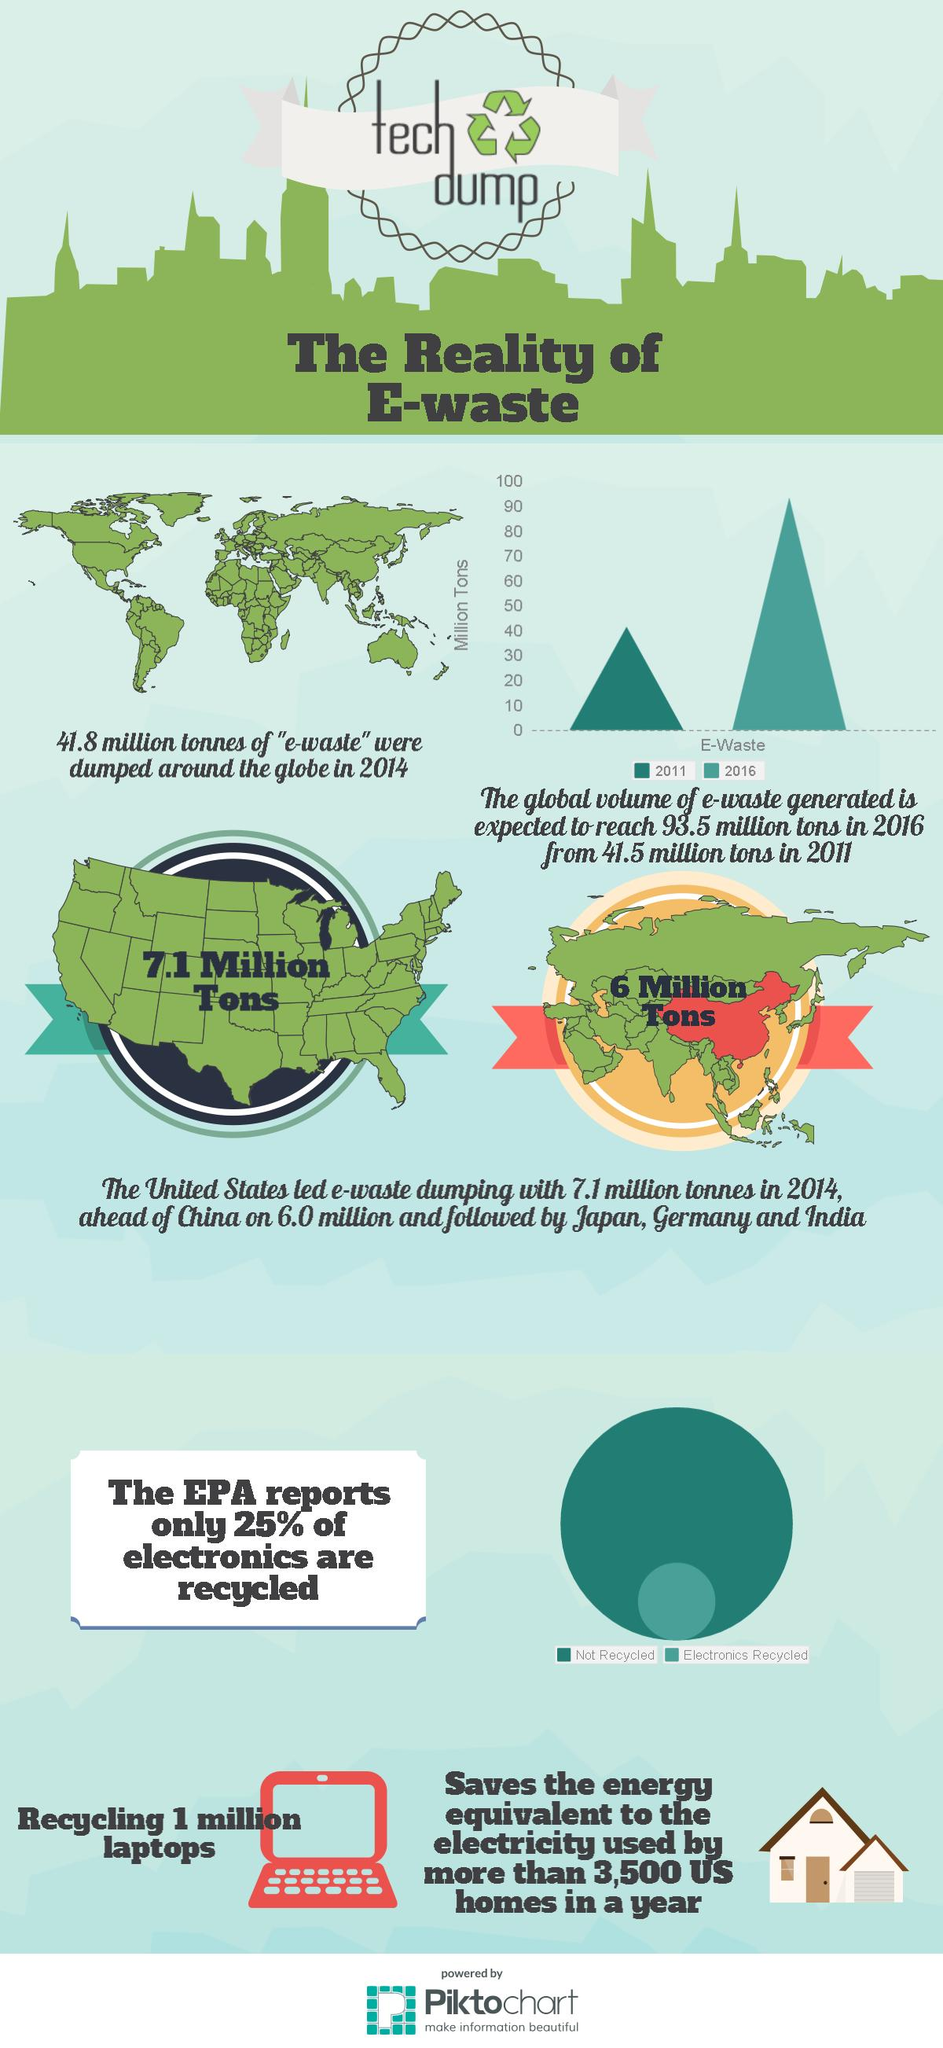Specify some key components in this picture. In 2016, the global volume of e-waste amounted to approximately 90 million tons. In 2016, the quantity of e-waste was at its highest. According to the EPA report, a staggering 75% of electronics are not properly recycled, leading to a significant amount of electronic waste ending up in landfills and other environments. The increase in electronic waste (e-waste) volume from 2011 to 2016 was approximately 52 million tonnes. The global volume of e-waste in 2011 was approximately 40 million tons. 